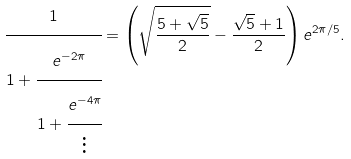Convert formula to latex. <formula><loc_0><loc_0><loc_500><loc_500>\cfrac { 1 } { 1 + \cfrac { e ^ { - 2 \pi } } { 1 + \cfrac { e ^ { - 4 \pi } } { \vdots } } } = \left ( \sqrt { \frac { 5 + \sqrt { 5 } } { 2 } } - \frac { \sqrt { 5 } + 1 } { 2 } \right ) e ^ { 2 \pi / 5 } .</formula> 